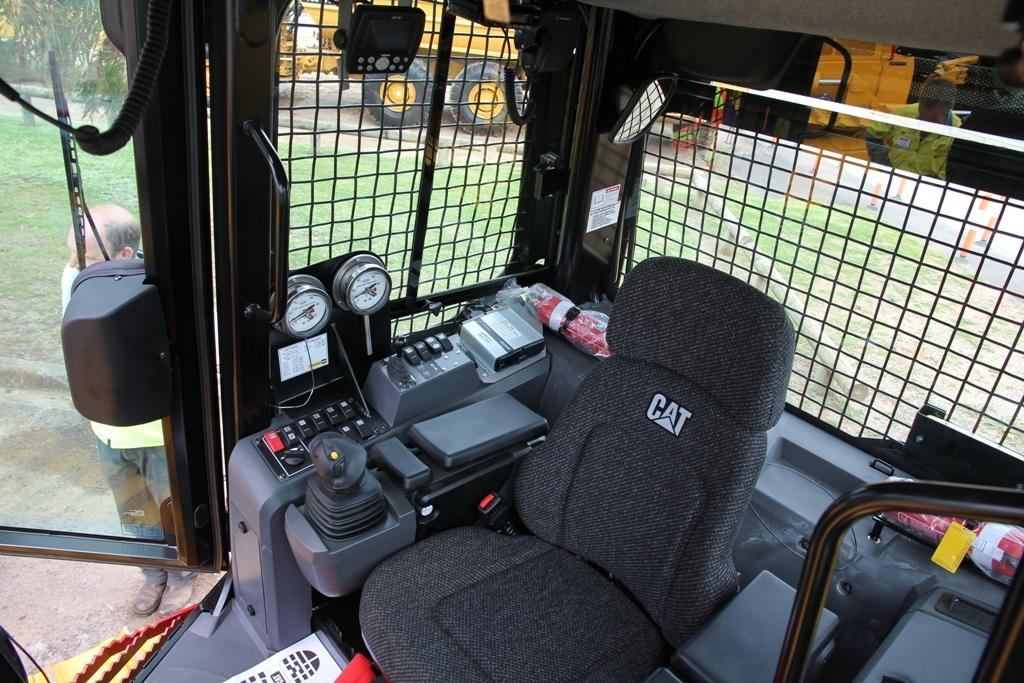Where was the image taken? The image was taken inside a vehicle. What can be seen in the middle of the vehicle? There is a seat in the middle of the vehicle. What is located near the seat? There are controls on either side of the seat. What is visible outside the vehicle? Outside the vehicle, there is a person standing on the grassland. What is the tendency of the ocean to rise in the image? There is no ocean present in the image, so it is not possible to determine any tendencies related to the ocean. 